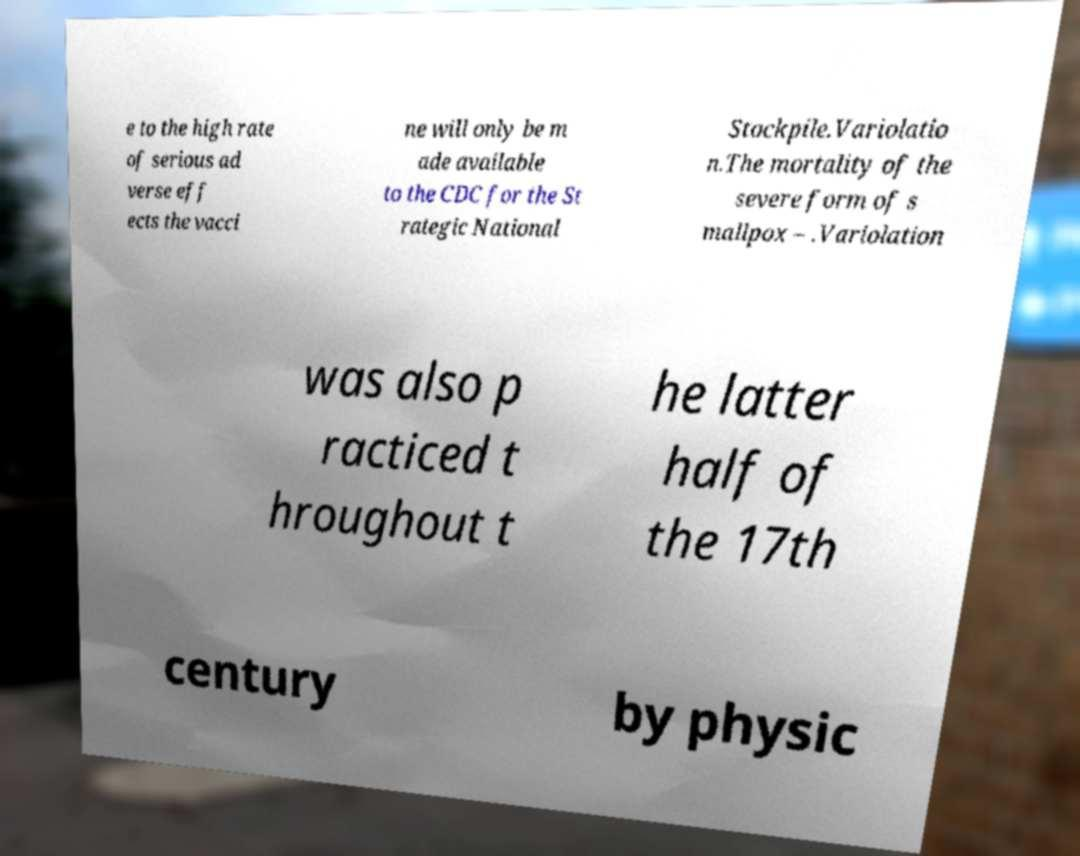I need the written content from this picture converted into text. Can you do that? e to the high rate of serious ad verse eff ects the vacci ne will only be m ade available to the CDC for the St rategic National Stockpile.Variolatio n.The mortality of the severe form of s mallpox – .Variolation was also p racticed t hroughout t he latter half of the 17th century by physic 